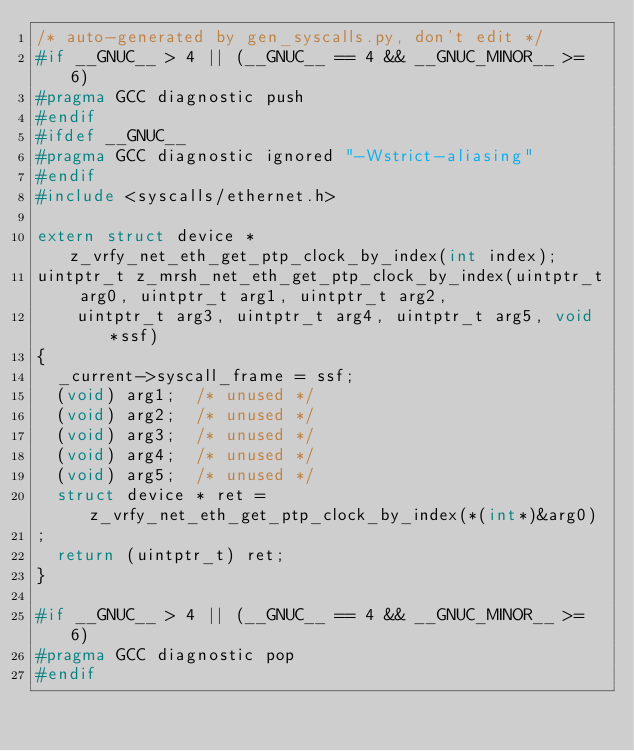<code> <loc_0><loc_0><loc_500><loc_500><_C_>/* auto-generated by gen_syscalls.py, don't edit */
#if __GNUC__ > 4 || (__GNUC__ == 4 && __GNUC_MINOR__ >= 6)
#pragma GCC diagnostic push
#endif
#ifdef __GNUC__
#pragma GCC diagnostic ignored "-Wstrict-aliasing"
#endif
#include <syscalls/ethernet.h>

extern struct device * z_vrfy_net_eth_get_ptp_clock_by_index(int index);
uintptr_t z_mrsh_net_eth_get_ptp_clock_by_index(uintptr_t arg0, uintptr_t arg1, uintptr_t arg2,
		uintptr_t arg3, uintptr_t arg4, uintptr_t arg5, void *ssf)
{
	_current->syscall_frame = ssf;
	(void) arg1;	/* unused */
	(void) arg2;	/* unused */
	(void) arg3;	/* unused */
	(void) arg4;	/* unused */
	(void) arg5;	/* unused */
	struct device * ret = z_vrfy_net_eth_get_ptp_clock_by_index(*(int*)&arg0)
;
	return (uintptr_t) ret;
}

#if __GNUC__ > 4 || (__GNUC__ == 4 && __GNUC_MINOR__ >= 6)
#pragma GCC diagnostic pop
#endif
</code> 